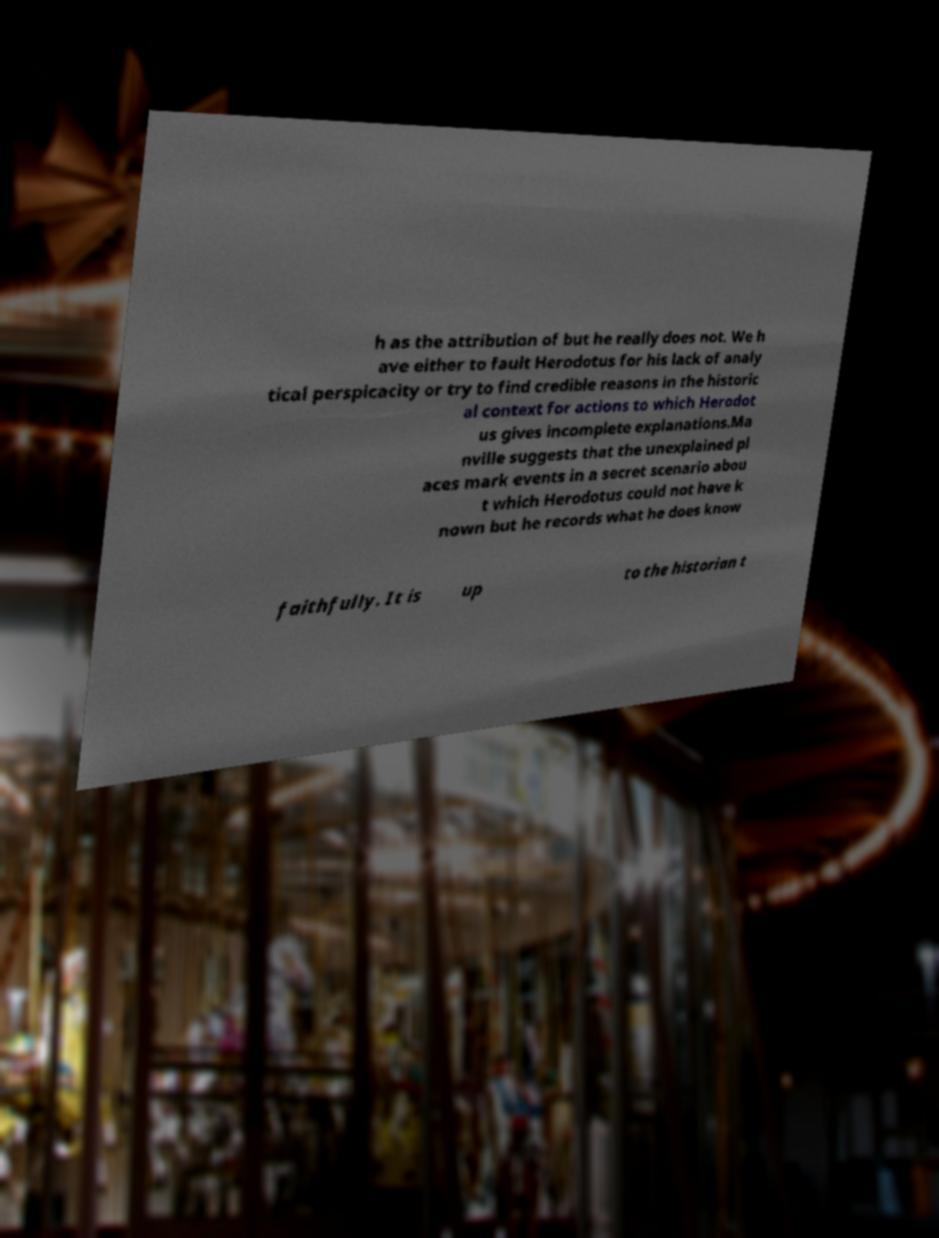I need the written content from this picture converted into text. Can you do that? h as the attribution of but he really does not. We h ave either to fault Herodotus for his lack of analy tical perspicacity or try to find credible reasons in the historic al context for actions to which Herodot us gives incomplete explanations.Ma nville suggests that the unexplained pl aces mark events in a secret scenario abou t which Herodotus could not have k nown but he records what he does know faithfully. It is up to the historian t 